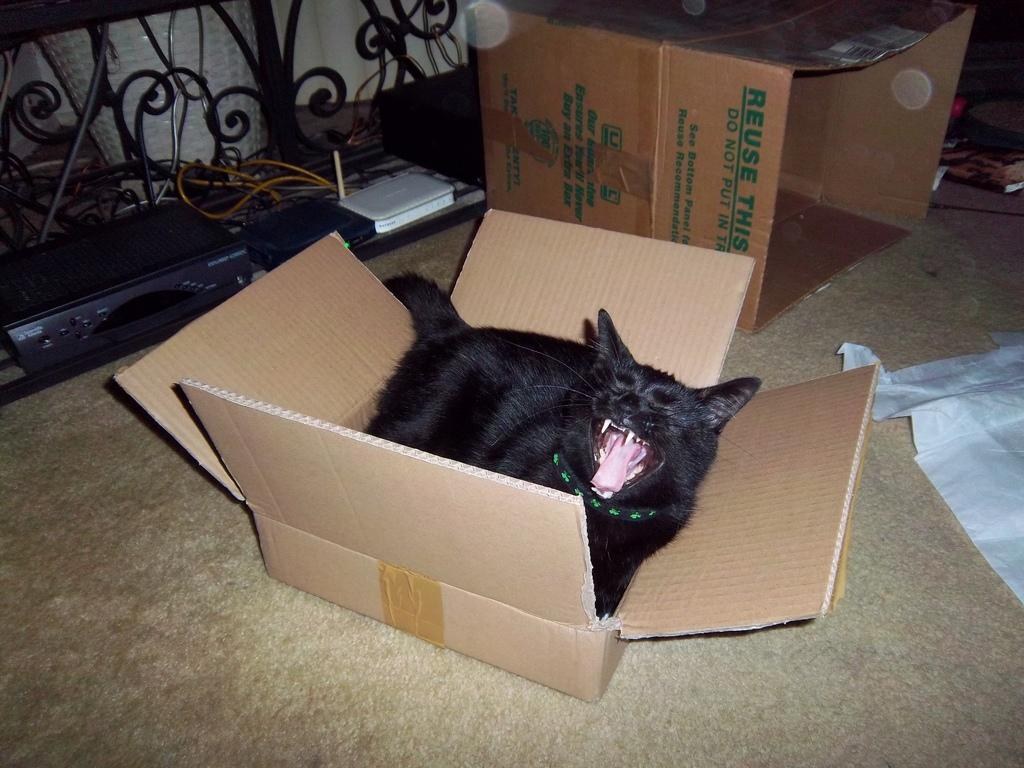<image>
Describe the image concisely. A cardboard box reads Reuse this for recycling. 